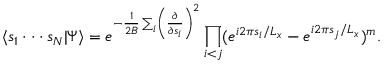<formula> <loc_0><loc_0><loc_500><loc_500>\langle s _ { 1 } \cdot \cdot \cdot s _ { N } | \Psi \rangle = e ^ { - { \frac { 1 } { 2 B } } \sum _ { i } \left ( { \frac { \partial } { \partial s _ { i } } } \right ) ^ { 2 } } \prod _ { i < j } ( e ^ { i 2 \pi s _ { i } / L _ { x } } - e ^ { i 2 \pi s _ { j } / L _ { x } } ) ^ { m } .</formula> 